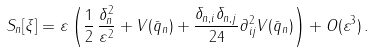<formula> <loc_0><loc_0><loc_500><loc_500>S _ { n } [ \xi ] = \varepsilon \left ( \frac { 1 } { 2 } \, \frac { \delta _ { n } ^ { 2 } } { \varepsilon ^ { 2 } } + V ( \bar { q } _ { n } ) + \frac { \delta _ { n , i } \delta _ { n , j } } { 2 4 } \partial _ { i j } ^ { 2 } V ( \bar { q } _ { n } ) \right ) + O ( \varepsilon ^ { 3 } ) \, .</formula> 